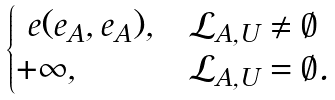<formula> <loc_0><loc_0><loc_500><loc_500>\begin{cases} \ e ( e _ { A } , e _ { A } ) , & \mathcal { L } _ { A , U } \neq \emptyset \\ + \infty , & \mathcal { L } _ { A , U } = \emptyset . \end{cases}</formula> 